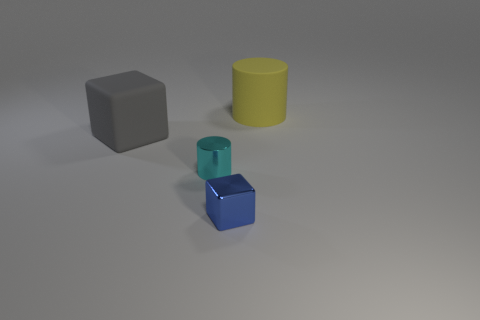What is the shape of the matte object in front of the cylinder that is behind the gray rubber cube?
Your answer should be very brief. Cube. Are there any gray blocks that have the same material as the small cyan thing?
Ensure brevity in your answer.  No. There is a cube that is to the right of the tiny cyan object; what material is it?
Make the answer very short. Metal. What material is the large block?
Give a very brief answer. Rubber. Is the cylinder behind the tiny cyan cylinder made of the same material as the cyan cylinder?
Offer a terse response. No. Is the number of large objects that are in front of the matte block less than the number of large blocks?
Your answer should be compact. Yes. There is a cylinder that is the same size as the shiny cube; what is its color?
Your answer should be very brief. Cyan. How many yellow rubber objects have the same shape as the tiny blue metallic thing?
Give a very brief answer. 0. The rubber thing that is on the left side of the yellow thing is what color?
Keep it short and to the point. Gray. What number of metallic objects are large cylinders or blue blocks?
Offer a very short reply. 1. 